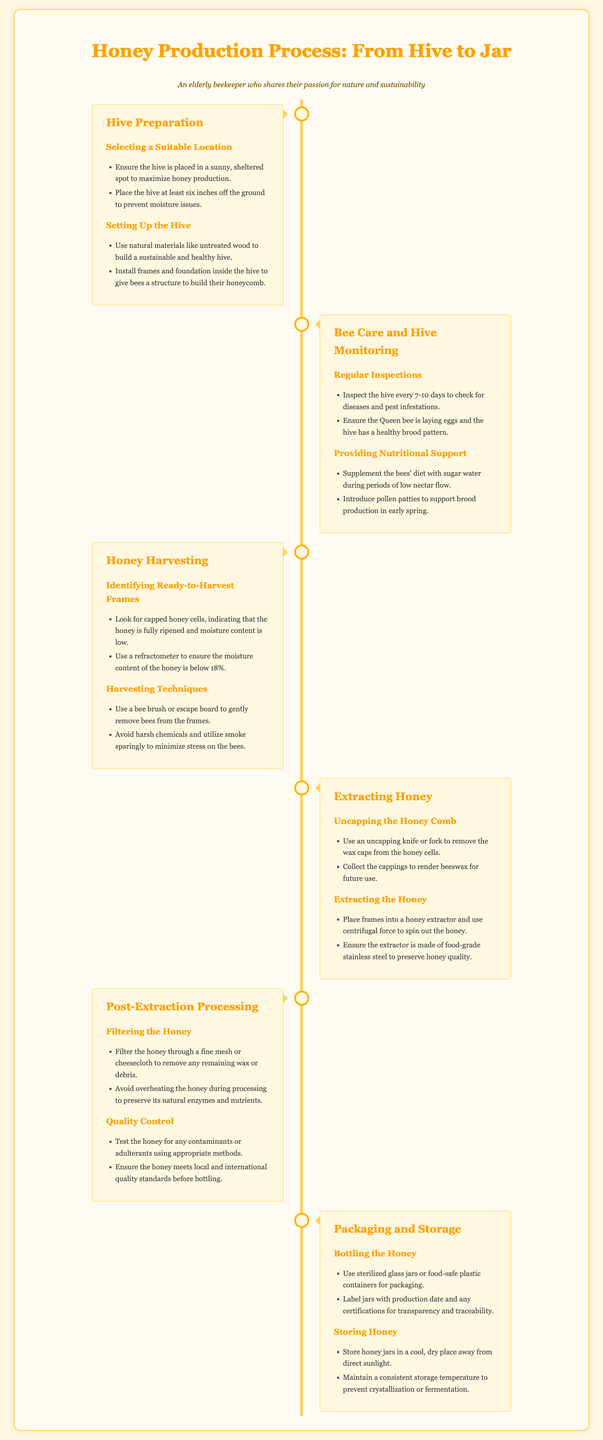what is the first step in honey production? The first step in honey production is Hive Preparation, which includes selecting a suitable location and setting up the hive.
Answer: Hive Preparation how often should the hive be inspected? Regular inspections should be done every 7-10 days to check for diseases and pest infestations.
Answer: 7-10 days what indicates that honey is ready to be harvested? Capped honey cells indicate that the honey is fully ripened and moisture content is low.
Answer: Capped honey cells what tool is used to remove wax caps from honey cells? An uncapping knife or fork is used to remove the wax caps from the honey cells.
Answer: Uncapping knife or fork how should honey be filtered after extraction? Honey should be filtered through a fine mesh or cheesecloth to remove any remaining wax or debris.
Answer: Fine mesh or cheesecloth what material should the honey extractor be made of? The honey extractor should be made of food-grade stainless steel to preserve honey quality.
Answer: Food-grade stainless steel where should honey jars be stored? Honey jars should be stored in a cool, dry place away from direct sunlight.
Answer: Cool, dry place what is essential for transparency and traceability when bottling honey? Jars should be labeled with the production date and any certifications.
Answer: Production date and certifications what is the maximum moisture content for harvested honey? The moisture content of the honey should be below 18%.
Answer: 18% 